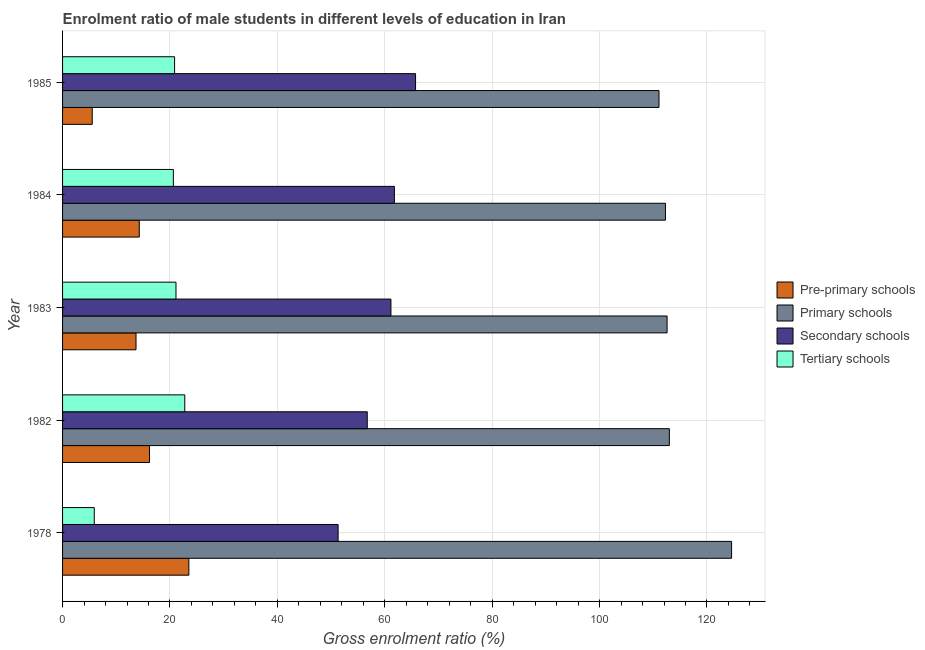How many groups of bars are there?
Give a very brief answer. 5. Are the number of bars per tick equal to the number of legend labels?
Give a very brief answer. Yes. Are the number of bars on each tick of the Y-axis equal?
Ensure brevity in your answer.  Yes. How many bars are there on the 2nd tick from the top?
Your answer should be compact. 4. What is the label of the 3rd group of bars from the top?
Your answer should be very brief. 1983. In how many cases, is the number of bars for a given year not equal to the number of legend labels?
Provide a succinct answer. 0. What is the gross enrolment ratio(female) in primary schools in 1985?
Make the answer very short. 111.07. Across all years, what is the maximum gross enrolment ratio(female) in primary schools?
Offer a terse response. 124.58. Across all years, what is the minimum gross enrolment ratio(female) in pre-primary schools?
Offer a very short reply. 5.52. In which year was the gross enrolment ratio(female) in secondary schools minimum?
Give a very brief answer. 1978. What is the total gross enrolment ratio(female) in secondary schools in the graph?
Offer a terse response. 296.73. What is the difference between the gross enrolment ratio(female) in tertiary schools in 1983 and that in 1984?
Your answer should be compact. 0.49. What is the difference between the gross enrolment ratio(female) in pre-primary schools in 1978 and the gross enrolment ratio(female) in secondary schools in 1982?
Provide a short and direct response. -33.22. What is the average gross enrolment ratio(female) in tertiary schools per year?
Ensure brevity in your answer.  18.25. In the year 1978, what is the difference between the gross enrolment ratio(female) in tertiary schools and gross enrolment ratio(female) in secondary schools?
Give a very brief answer. -45.41. What is the ratio of the gross enrolment ratio(female) in tertiary schools in 1983 to that in 1985?
Provide a short and direct response. 1.01. Is the difference between the gross enrolment ratio(female) in secondary schools in 1978 and 1983 greater than the difference between the gross enrolment ratio(female) in tertiary schools in 1978 and 1983?
Offer a very short reply. Yes. What is the difference between the highest and the second highest gross enrolment ratio(female) in pre-primary schools?
Keep it short and to the point. 7.33. What is the difference between the highest and the lowest gross enrolment ratio(female) in pre-primary schools?
Keep it short and to the point. 17.99. In how many years, is the gross enrolment ratio(female) in secondary schools greater than the average gross enrolment ratio(female) in secondary schools taken over all years?
Your response must be concise. 3. Is it the case that in every year, the sum of the gross enrolment ratio(female) in primary schools and gross enrolment ratio(female) in secondary schools is greater than the sum of gross enrolment ratio(female) in pre-primary schools and gross enrolment ratio(female) in tertiary schools?
Your answer should be very brief. Yes. What does the 3rd bar from the top in 1978 represents?
Ensure brevity in your answer.  Primary schools. What does the 4th bar from the bottom in 1984 represents?
Make the answer very short. Tertiary schools. Is it the case that in every year, the sum of the gross enrolment ratio(female) in pre-primary schools and gross enrolment ratio(female) in primary schools is greater than the gross enrolment ratio(female) in secondary schools?
Provide a short and direct response. Yes. How many bars are there?
Offer a terse response. 20. How many years are there in the graph?
Ensure brevity in your answer.  5. Does the graph contain any zero values?
Offer a terse response. No. How many legend labels are there?
Offer a very short reply. 4. How are the legend labels stacked?
Provide a succinct answer. Vertical. What is the title of the graph?
Ensure brevity in your answer.  Enrolment ratio of male students in different levels of education in Iran. What is the Gross enrolment ratio (%) of Pre-primary schools in 1978?
Offer a very short reply. 23.52. What is the Gross enrolment ratio (%) of Primary schools in 1978?
Your answer should be compact. 124.58. What is the Gross enrolment ratio (%) in Secondary schools in 1978?
Offer a terse response. 51.31. What is the Gross enrolment ratio (%) in Tertiary schools in 1978?
Offer a very short reply. 5.9. What is the Gross enrolment ratio (%) in Pre-primary schools in 1982?
Ensure brevity in your answer.  16.19. What is the Gross enrolment ratio (%) in Primary schools in 1982?
Keep it short and to the point. 113. What is the Gross enrolment ratio (%) in Secondary schools in 1982?
Provide a succinct answer. 56.74. What is the Gross enrolment ratio (%) of Tertiary schools in 1982?
Ensure brevity in your answer.  22.76. What is the Gross enrolment ratio (%) of Pre-primary schools in 1983?
Give a very brief answer. 13.68. What is the Gross enrolment ratio (%) of Primary schools in 1983?
Your answer should be very brief. 112.57. What is the Gross enrolment ratio (%) in Secondary schools in 1983?
Provide a short and direct response. 61.15. What is the Gross enrolment ratio (%) of Tertiary schools in 1983?
Make the answer very short. 21.12. What is the Gross enrolment ratio (%) of Pre-primary schools in 1984?
Ensure brevity in your answer.  14.29. What is the Gross enrolment ratio (%) in Primary schools in 1984?
Your answer should be very brief. 112.27. What is the Gross enrolment ratio (%) in Secondary schools in 1984?
Your answer should be very brief. 61.79. What is the Gross enrolment ratio (%) of Tertiary schools in 1984?
Offer a very short reply. 20.63. What is the Gross enrolment ratio (%) of Pre-primary schools in 1985?
Provide a short and direct response. 5.52. What is the Gross enrolment ratio (%) in Primary schools in 1985?
Your response must be concise. 111.07. What is the Gross enrolment ratio (%) in Secondary schools in 1985?
Provide a short and direct response. 65.74. What is the Gross enrolment ratio (%) of Tertiary schools in 1985?
Your response must be concise. 20.86. Across all years, what is the maximum Gross enrolment ratio (%) in Pre-primary schools?
Give a very brief answer. 23.52. Across all years, what is the maximum Gross enrolment ratio (%) of Primary schools?
Provide a short and direct response. 124.58. Across all years, what is the maximum Gross enrolment ratio (%) in Secondary schools?
Your answer should be very brief. 65.74. Across all years, what is the maximum Gross enrolment ratio (%) in Tertiary schools?
Your answer should be very brief. 22.76. Across all years, what is the minimum Gross enrolment ratio (%) of Pre-primary schools?
Offer a very short reply. 5.52. Across all years, what is the minimum Gross enrolment ratio (%) in Primary schools?
Keep it short and to the point. 111.07. Across all years, what is the minimum Gross enrolment ratio (%) in Secondary schools?
Provide a succinct answer. 51.31. Across all years, what is the minimum Gross enrolment ratio (%) of Tertiary schools?
Give a very brief answer. 5.9. What is the total Gross enrolment ratio (%) in Pre-primary schools in the graph?
Provide a succinct answer. 73.2. What is the total Gross enrolment ratio (%) of Primary schools in the graph?
Keep it short and to the point. 573.5. What is the total Gross enrolment ratio (%) in Secondary schools in the graph?
Make the answer very short. 296.73. What is the total Gross enrolment ratio (%) in Tertiary schools in the graph?
Keep it short and to the point. 91.28. What is the difference between the Gross enrolment ratio (%) of Pre-primary schools in 1978 and that in 1982?
Your answer should be compact. 7.33. What is the difference between the Gross enrolment ratio (%) of Primary schools in 1978 and that in 1982?
Your answer should be compact. 11.59. What is the difference between the Gross enrolment ratio (%) of Secondary schools in 1978 and that in 1982?
Ensure brevity in your answer.  -5.43. What is the difference between the Gross enrolment ratio (%) in Tertiary schools in 1978 and that in 1982?
Provide a short and direct response. -16.86. What is the difference between the Gross enrolment ratio (%) in Pre-primary schools in 1978 and that in 1983?
Provide a short and direct response. 9.84. What is the difference between the Gross enrolment ratio (%) in Primary schools in 1978 and that in 1983?
Provide a short and direct response. 12.01. What is the difference between the Gross enrolment ratio (%) in Secondary schools in 1978 and that in 1983?
Offer a very short reply. -9.84. What is the difference between the Gross enrolment ratio (%) of Tertiary schools in 1978 and that in 1983?
Provide a succinct answer. -15.22. What is the difference between the Gross enrolment ratio (%) in Pre-primary schools in 1978 and that in 1984?
Your response must be concise. 9.23. What is the difference between the Gross enrolment ratio (%) of Primary schools in 1978 and that in 1984?
Provide a succinct answer. 12.31. What is the difference between the Gross enrolment ratio (%) of Secondary schools in 1978 and that in 1984?
Provide a short and direct response. -10.48. What is the difference between the Gross enrolment ratio (%) in Tertiary schools in 1978 and that in 1984?
Provide a short and direct response. -14.73. What is the difference between the Gross enrolment ratio (%) in Pre-primary schools in 1978 and that in 1985?
Your response must be concise. 17.99. What is the difference between the Gross enrolment ratio (%) of Primary schools in 1978 and that in 1985?
Provide a succinct answer. 13.51. What is the difference between the Gross enrolment ratio (%) of Secondary schools in 1978 and that in 1985?
Offer a terse response. -14.42. What is the difference between the Gross enrolment ratio (%) in Tertiary schools in 1978 and that in 1985?
Give a very brief answer. -14.96. What is the difference between the Gross enrolment ratio (%) in Pre-primary schools in 1982 and that in 1983?
Your answer should be very brief. 2.51. What is the difference between the Gross enrolment ratio (%) in Primary schools in 1982 and that in 1983?
Your response must be concise. 0.43. What is the difference between the Gross enrolment ratio (%) of Secondary schools in 1982 and that in 1983?
Ensure brevity in your answer.  -4.41. What is the difference between the Gross enrolment ratio (%) in Tertiary schools in 1982 and that in 1983?
Offer a terse response. 1.64. What is the difference between the Gross enrolment ratio (%) in Pre-primary schools in 1982 and that in 1984?
Offer a very short reply. 1.9. What is the difference between the Gross enrolment ratio (%) in Primary schools in 1982 and that in 1984?
Your answer should be compact. 0.73. What is the difference between the Gross enrolment ratio (%) of Secondary schools in 1982 and that in 1984?
Make the answer very short. -5.06. What is the difference between the Gross enrolment ratio (%) of Tertiary schools in 1982 and that in 1984?
Make the answer very short. 2.13. What is the difference between the Gross enrolment ratio (%) of Pre-primary schools in 1982 and that in 1985?
Your answer should be compact. 10.66. What is the difference between the Gross enrolment ratio (%) in Primary schools in 1982 and that in 1985?
Provide a short and direct response. 1.93. What is the difference between the Gross enrolment ratio (%) in Secondary schools in 1982 and that in 1985?
Offer a terse response. -9. What is the difference between the Gross enrolment ratio (%) in Tertiary schools in 1982 and that in 1985?
Ensure brevity in your answer.  1.9. What is the difference between the Gross enrolment ratio (%) of Pre-primary schools in 1983 and that in 1984?
Offer a very short reply. -0.61. What is the difference between the Gross enrolment ratio (%) of Primary schools in 1983 and that in 1984?
Offer a very short reply. 0.3. What is the difference between the Gross enrolment ratio (%) of Secondary schools in 1983 and that in 1984?
Your answer should be compact. -0.64. What is the difference between the Gross enrolment ratio (%) of Tertiary schools in 1983 and that in 1984?
Make the answer very short. 0.49. What is the difference between the Gross enrolment ratio (%) in Pre-primary schools in 1983 and that in 1985?
Your answer should be compact. 8.15. What is the difference between the Gross enrolment ratio (%) of Primary schools in 1983 and that in 1985?
Provide a succinct answer. 1.5. What is the difference between the Gross enrolment ratio (%) in Secondary schools in 1983 and that in 1985?
Offer a very short reply. -4.59. What is the difference between the Gross enrolment ratio (%) in Tertiary schools in 1983 and that in 1985?
Provide a succinct answer. 0.26. What is the difference between the Gross enrolment ratio (%) in Pre-primary schools in 1984 and that in 1985?
Provide a short and direct response. 8.76. What is the difference between the Gross enrolment ratio (%) of Primary schools in 1984 and that in 1985?
Offer a very short reply. 1.2. What is the difference between the Gross enrolment ratio (%) of Secondary schools in 1984 and that in 1985?
Your answer should be compact. -3.94. What is the difference between the Gross enrolment ratio (%) in Tertiary schools in 1984 and that in 1985?
Keep it short and to the point. -0.23. What is the difference between the Gross enrolment ratio (%) of Pre-primary schools in 1978 and the Gross enrolment ratio (%) of Primary schools in 1982?
Your answer should be compact. -89.48. What is the difference between the Gross enrolment ratio (%) in Pre-primary schools in 1978 and the Gross enrolment ratio (%) in Secondary schools in 1982?
Give a very brief answer. -33.22. What is the difference between the Gross enrolment ratio (%) of Pre-primary schools in 1978 and the Gross enrolment ratio (%) of Tertiary schools in 1982?
Your response must be concise. 0.76. What is the difference between the Gross enrolment ratio (%) in Primary schools in 1978 and the Gross enrolment ratio (%) in Secondary schools in 1982?
Offer a terse response. 67.85. What is the difference between the Gross enrolment ratio (%) of Primary schools in 1978 and the Gross enrolment ratio (%) of Tertiary schools in 1982?
Offer a terse response. 101.83. What is the difference between the Gross enrolment ratio (%) of Secondary schools in 1978 and the Gross enrolment ratio (%) of Tertiary schools in 1982?
Provide a succinct answer. 28.55. What is the difference between the Gross enrolment ratio (%) in Pre-primary schools in 1978 and the Gross enrolment ratio (%) in Primary schools in 1983?
Your answer should be compact. -89.06. What is the difference between the Gross enrolment ratio (%) of Pre-primary schools in 1978 and the Gross enrolment ratio (%) of Secondary schools in 1983?
Your response must be concise. -37.63. What is the difference between the Gross enrolment ratio (%) of Pre-primary schools in 1978 and the Gross enrolment ratio (%) of Tertiary schools in 1983?
Give a very brief answer. 2.4. What is the difference between the Gross enrolment ratio (%) of Primary schools in 1978 and the Gross enrolment ratio (%) of Secondary schools in 1983?
Offer a very short reply. 63.43. What is the difference between the Gross enrolment ratio (%) of Primary schools in 1978 and the Gross enrolment ratio (%) of Tertiary schools in 1983?
Your answer should be very brief. 103.46. What is the difference between the Gross enrolment ratio (%) of Secondary schools in 1978 and the Gross enrolment ratio (%) of Tertiary schools in 1983?
Your response must be concise. 30.19. What is the difference between the Gross enrolment ratio (%) in Pre-primary schools in 1978 and the Gross enrolment ratio (%) in Primary schools in 1984?
Ensure brevity in your answer.  -88.75. What is the difference between the Gross enrolment ratio (%) in Pre-primary schools in 1978 and the Gross enrolment ratio (%) in Secondary schools in 1984?
Make the answer very short. -38.28. What is the difference between the Gross enrolment ratio (%) of Pre-primary schools in 1978 and the Gross enrolment ratio (%) of Tertiary schools in 1984?
Offer a very short reply. 2.89. What is the difference between the Gross enrolment ratio (%) of Primary schools in 1978 and the Gross enrolment ratio (%) of Secondary schools in 1984?
Offer a terse response. 62.79. What is the difference between the Gross enrolment ratio (%) in Primary schools in 1978 and the Gross enrolment ratio (%) in Tertiary schools in 1984?
Your answer should be very brief. 103.95. What is the difference between the Gross enrolment ratio (%) in Secondary schools in 1978 and the Gross enrolment ratio (%) in Tertiary schools in 1984?
Your answer should be very brief. 30.68. What is the difference between the Gross enrolment ratio (%) of Pre-primary schools in 1978 and the Gross enrolment ratio (%) of Primary schools in 1985?
Ensure brevity in your answer.  -87.55. What is the difference between the Gross enrolment ratio (%) of Pre-primary schools in 1978 and the Gross enrolment ratio (%) of Secondary schools in 1985?
Offer a terse response. -42.22. What is the difference between the Gross enrolment ratio (%) of Pre-primary schools in 1978 and the Gross enrolment ratio (%) of Tertiary schools in 1985?
Your answer should be very brief. 2.65. What is the difference between the Gross enrolment ratio (%) of Primary schools in 1978 and the Gross enrolment ratio (%) of Secondary schools in 1985?
Provide a short and direct response. 58.85. What is the difference between the Gross enrolment ratio (%) of Primary schools in 1978 and the Gross enrolment ratio (%) of Tertiary schools in 1985?
Give a very brief answer. 103.72. What is the difference between the Gross enrolment ratio (%) in Secondary schools in 1978 and the Gross enrolment ratio (%) in Tertiary schools in 1985?
Provide a succinct answer. 30.45. What is the difference between the Gross enrolment ratio (%) in Pre-primary schools in 1982 and the Gross enrolment ratio (%) in Primary schools in 1983?
Offer a very short reply. -96.38. What is the difference between the Gross enrolment ratio (%) in Pre-primary schools in 1982 and the Gross enrolment ratio (%) in Secondary schools in 1983?
Make the answer very short. -44.96. What is the difference between the Gross enrolment ratio (%) in Pre-primary schools in 1982 and the Gross enrolment ratio (%) in Tertiary schools in 1983?
Ensure brevity in your answer.  -4.93. What is the difference between the Gross enrolment ratio (%) of Primary schools in 1982 and the Gross enrolment ratio (%) of Secondary schools in 1983?
Provide a succinct answer. 51.85. What is the difference between the Gross enrolment ratio (%) of Primary schools in 1982 and the Gross enrolment ratio (%) of Tertiary schools in 1983?
Give a very brief answer. 91.88. What is the difference between the Gross enrolment ratio (%) in Secondary schools in 1982 and the Gross enrolment ratio (%) in Tertiary schools in 1983?
Provide a succinct answer. 35.62. What is the difference between the Gross enrolment ratio (%) of Pre-primary schools in 1982 and the Gross enrolment ratio (%) of Primary schools in 1984?
Offer a very short reply. -96.08. What is the difference between the Gross enrolment ratio (%) in Pre-primary schools in 1982 and the Gross enrolment ratio (%) in Secondary schools in 1984?
Give a very brief answer. -45.61. What is the difference between the Gross enrolment ratio (%) in Pre-primary schools in 1982 and the Gross enrolment ratio (%) in Tertiary schools in 1984?
Provide a succinct answer. -4.44. What is the difference between the Gross enrolment ratio (%) in Primary schools in 1982 and the Gross enrolment ratio (%) in Secondary schools in 1984?
Your answer should be very brief. 51.21. What is the difference between the Gross enrolment ratio (%) in Primary schools in 1982 and the Gross enrolment ratio (%) in Tertiary schools in 1984?
Provide a succinct answer. 92.37. What is the difference between the Gross enrolment ratio (%) of Secondary schools in 1982 and the Gross enrolment ratio (%) of Tertiary schools in 1984?
Your answer should be compact. 36.11. What is the difference between the Gross enrolment ratio (%) in Pre-primary schools in 1982 and the Gross enrolment ratio (%) in Primary schools in 1985?
Keep it short and to the point. -94.88. What is the difference between the Gross enrolment ratio (%) of Pre-primary schools in 1982 and the Gross enrolment ratio (%) of Secondary schools in 1985?
Make the answer very short. -49.55. What is the difference between the Gross enrolment ratio (%) in Pre-primary schools in 1982 and the Gross enrolment ratio (%) in Tertiary schools in 1985?
Your response must be concise. -4.67. What is the difference between the Gross enrolment ratio (%) of Primary schools in 1982 and the Gross enrolment ratio (%) of Secondary schools in 1985?
Keep it short and to the point. 47.26. What is the difference between the Gross enrolment ratio (%) in Primary schools in 1982 and the Gross enrolment ratio (%) in Tertiary schools in 1985?
Keep it short and to the point. 92.14. What is the difference between the Gross enrolment ratio (%) of Secondary schools in 1982 and the Gross enrolment ratio (%) of Tertiary schools in 1985?
Offer a terse response. 35.88. What is the difference between the Gross enrolment ratio (%) of Pre-primary schools in 1983 and the Gross enrolment ratio (%) of Primary schools in 1984?
Keep it short and to the point. -98.59. What is the difference between the Gross enrolment ratio (%) in Pre-primary schools in 1983 and the Gross enrolment ratio (%) in Secondary schools in 1984?
Provide a succinct answer. -48.12. What is the difference between the Gross enrolment ratio (%) in Pre-primary schools in 1983 and the Gross enrolment ratio (%) in Tertiary schools in 1984?
Your answer should be very brief. -6.95. What is the difference between the Gross enrolment ratio (%) in Primary schools in 1983 and the Gross enrolment ratio (%) in Secondary schools in 1984?
Offer a terse response. 50.78. What is the difference between the Gross enrolment ratio (%) of Primary schools in 1983 and the Gross enrolment ratio (%) of Tertiary schools in 1984?
Ensure brevity in your answer.  91.94. What is the difference between the Gross enrolment ratio (%) of Secondary schools in 1983 and the Gross enrolment ratio (%) of Tertiary schools in 1984?
Your answer should be very brief. 40.52. What is the difference between the Gross enrolment ratio (%) of Pre-primary schools in 1983 and the Gross enrolment ratio (%) of Primary schools in 1985?
Your answer should be very brief. -97.39. What is the difference between the Gross enrolment ratio (%) in Pre-primary schools in 1983 and the Gross enrolment ratio (%) in Secondary schools in 1985?
Provide a succinct answer. -52.06. What is the difference between the Gross enrolment ratio (%) of Pre-primary schools in 1983 and the Gross enrolment ratio (%) of Tertiary schools in 1985?
Provide a succinct answer. -7.18. What is the difference between the Gross enrolment ratio (%) of Primary schools in 1983 and the Gross enrolment ratio (%) of Secondary schools in 1985?
Make the answer very short. 46.84. What is the difference between the Gross enrolment ratio (%) of Primary schools in 1983 and the Gross enrolment ratio (%) of Tertiary schools in 1985?
Ensure brevity in your answer.  91.71. What is the difference between the Gross enrolment ratio (%) in Secondary schools in 1983 and the Gross enrolment ratio (%) in Tertiary schools in 1985?
Provide a short and direct response. 40.29. What is the difference between the Gross enrolment ratio (%) in Pre-primary schools in 1984 and the Gross enrolment ratio (%) in Primary schools in 1985?
Offer a very short reply. -96.78. What is the difference between the Gross enrolment ratio (%) of Pre-primary schools in 1984 and the Gross enrolment ratio (%) of Secondary schools in 1985?
Keep it short and to the point. -51.45. What is the difference between the Gross enrolment ratio (%) of Pre-primary schools in 1984 and the Gross enrolment ratio (%) of Tertiary schools in 1985?
Make the answer very short. -6.58. What is the difference between the Gross enrolment ratio (%) of Primary schools in 1984 and the Gross enrolment ratio (%) of Secondary schools in 1985?
Provide a succinct answer. 46.53. What is the difference between the Gross enrolment ratio (%) of Primary schools in 1984 and the Gross enrolment ratio (%) of Tertiary schools in 1985?
Give a very brief answer. 91.41. What is the difference between the Gross enrolment ratio (%) in Secondary schools in 1984 and the Gross enrolment ratio (%) in Tertiary schools in 1985?
Offer a very short reply. 40.93. What is the average Gross enrolment ratio (%) in Pre-primary schools per year?
Ensure brevity in your answer.  14.64. What is the average Gross enrolment ratio (%) in Primary schools per year?
Keep it short and to the point. 114.7. What is the average Gross enrolment ratio (%) in Secondary schools per year?
Your response must be concise. 59.35. What is the average Gross enrolment ratio (%) of Tertiary schools per year?
Keep it short and to the point. 18.26. In the year 1978, what is the difference between the Gross enrolment ratio (%) in Pre-primary schools and Gross enrolment ratio (%) in Primary schools?
Offer a very short reply. -101.07. In the year 1978, what is the difference between the Gross enrolment ratio (%) in Pre-primary schools and Gross enrolment ratio (%) in Secondary schools?
Ensure brevity in your answer.  -27.8. In the year 1978, what is the difference between the Gross enrolment ratio (%) in Pre-primary schools and Gross enrolment ratio (%) in Tertiary schools?
Give a very brief answer. 17.62. In the year 1978, what is the difference between the Gross enrolment ratio (%) of Primary schools and Gross enrolment ratio (%) of Secondary schools?
Make the answer very short. 73.27. In the year 1978, what is the difference between the Gross enrolment ratio (%) in Primary schools and Gross enrolment ratio (%) in Tertiary schools?
Offer a very short reply. 118.68. In the year 1978, what is the difference between the Gross enrolment ratio (%) of Secondary schools and Gross enrolment ratio (%) of Tertiary schools?
Offer a very short reply. 45.41. In the year 1982, what is the difference between the Gross enrolment ratio (%) in Pre-primary schools and Gross enrolment ratio (%) in Primary schools?
Your answer should be compact. -96.81. In the year 1982, what is the difference between the Gross enrolment ratio (%) of Pre-primary schools and Gross enrolment ratio (%) of Secondary schools?
Your response must be concise. -40.55. In the year 1982, what is the difference between the Gross enrolment ratio (%) in Pre-primary schools and Gross enrolment ratio (%) in Tertiary schools?
Make the answer very short. -6.57. In the year 1982, what is the difference between the Gross enrolment ratio (%) of Primary schools and Gross enrolment ratio (%) of Secondary schools?
Keep it short and to the point. 56.26. In the year 1982, what is the difference between the Gross enrolment ratio (%) in Primary schools and Gross enrolment ratio (%) in Tertiary schools?
Your answer should be very brief. 90.24. In the year 1982, what is the difference between the Gross enrolment ratio (%) in Secondary schools and Gross enrolment ratio (%) in Tertiary schools?
Your answer should be very brief. 33.98. In the year 1983, what is the difference between the Gross enrolment ratio (%) in Pre-primary schools and Gross enrolment ratio (%) in Primary schools?
Provide a short and direct response. -98.89. In the year 1983, what is the difference between the Gross enrolment ratio (%) of Pre-primary schools and Gross enrolment ratio (%) of Secondary schools?
Offer a terse response. -47.47. In the year 1983, what is the difference between the Gross enrolment ratio (%) of Pre-primary schools and Gross enrolment ratio (%) of Tertiary schools?
Keep it short and to the point. -7.44. In the year 1983, what is the difference between the Gross enrolment ratio (%) in Primary schools and Gross enrolment ratio (%) in Secondary schools?
Offer a very short reply. 51.42. In the year 1983, what is the difference between the Gross enrolment ratio (%) in Primary schools and Gross enrolment ratio (%) in Tertiary schools?
Your answer should be compact. 91.45. In the year 1983, what is the difference between the Gross enrolment ratio (%) in Secondary schools and Gross enrolment ratio (%) in Tertiary schools?
Your answer should be compact. 40.03. In the year 1984, what is the difference between the Gross enrolment ratio (%) of Pre-primary schools and Gross enrolment ratio (%) of Primary schools?
Your answer should be compact. -97.98. In the year 1984, what is the difference between the Gross enrolment ratio (%) of Pre-primary schools and Gross enrolment ratio (%) of Secondary schools?
Offer a very short reply. -47.51. In the year 1984, what is the difference between the Gross enrolment ratio (%) in Pre-primary schools and Gross enrolment ratio (%) in Tertiary schools?
Provide a succinct answer. -6.34. In the year 1984, what is the difference between the Gross enrolment ratio (%) of Primary schools and Gross enrolment ratio (%) of Secondary schools?
Offer a very short reply. 50.48. In the year 1984, what is the difference between the Gross enrolment ratio (%) in Primary schools and Gross enrolment ratio (%) in Tertiary schools?
Your response must be concise. 91.64. In the year 1984, what is the difference between the Gross enrolment ratio (%) of Secondary schools and Gross enrolment ratio (%) of Tertiary schools?
Provide a succinct answer. 41.16. In the year 1985, what is the difference between the Gross enrolment ratio (%) in Pre-primary schools and Gross enrolment ratio (%) in Primary schools?
Your answer should be very brief. -105.55. In the year 1985, what is the difference between the Gross enrolment ratio (%) of Pre-primary schools and Gross enrolment ratio (%) of Secondary schools?
Offer a very short reply. -60.21. In the year 1985, what is the difference between the Gross enrolment ratio (%) of Pre-primary schools and Gross enrolment ratio (%) of Tertiary schools?
Offer a terse response. -15.34. In the year 1985, what is the difference between the Gross enrolment ratio (%) of Primary schools and Gross enrolment ratio (%) of Secondary schools?
Offer a very short reply. 45.33. In the year 1985, what is the difference between the Gross enrolment ratio (%) of Primary schools and Gross enrolment ratio (%) of Tertiary schools?
Offer a terse response. 90.21. In the year 1985, what is the difference between the Gross enrolment ratio (%) of Secondary schools and Gross enrolment ratio (%) of Tertiary schools?
Make the answer very short. 44.87. What is the ratio of the Gross enrolment ratio (%) in Pre-primary schools in 1978 to that in 1982?
Provide a succinct answer. 1.45. What is the ratio of the Gross enrolment ratio (%) of Primary schools in 1978 to that in 1982?
Give a very brief answer. 1.1. What is the ratio of the Gross enrolment ratio (%) of Secondary schools in 1978 to that in 1982?
Your answer should be very brief. 0.9. What is the ratio of the Gross enrolment ratio (%) of Tertiary schools in 1978 to that in 1982?
Your response must be concise. 0.26. What is the ratio of the Gross enrolment ratio (%) in Pre-primary schools in 1978 to that in 1983?
Your answer should be compact. 1.72. What is the ratio of the Gross enrolment ratio (%) in Primary schools in 1978 to that in 1983?
Your answer should be compact. 1.11. What is the ratio of the Gross enrolment ratio (%) of Secondary schools in 1978 to that in 1983?
Offer a very short reply. 0.84. What is the ratio of the Gross enrolment ratio (%) in Tertiary schools in 1978 to that in 1983?
Provide a short and direct response. 0.28. What is the ratio of the Gross enrolment ratio (%) of Pre-primary schools in 1978 to that in 1984?
Offer a very short reply. 1.65. What is the ratio of the Gross enrolment ratio (%) in Primary schools in 1978 to that in 1984?
Provide a short and direct response. 1.11. What is the ratio of the Gross enrolment ratio (%) in Secondary schools in 1978 to that in 1984?
Keep it short and to the point. 0.83. What is the ratio of the Gross enrolment ratio (%) of Tertiary schools in 1978 to that in 1984?
Your answer should be very brief. 0.29. What is the ratio of the Gross enrolment ratio (%) in Pre-primary schools in 1978 to that in 1985?
Provide a succinct answer. 4.26. What is the ratio of the Gross enrolment ratio (%) in Primary schools in 1978 to that in 1985?
Give a very brief answer. 1.12. What is the ratio of the Gross enrolment ratio (%) of Secondary schools in 1978 to that in 1985?
Ensure brevity in your answer.  0.78. What is the ratio of the Gross enrolment ratio (%) in Tertiary schools in 1978 to that in 1985?
Keep it short and to the point. 0.28. What is the ratio of the Gross enrolment ratio (%) in Pre-primary schools in 1982 to that in 1983?
Offer a very short reply. 1.18. What is the ratio of the Gross enrolment ratio (%) in Secondary schools in 1982 to that in 1983?
Make the answer very short. 0.93. What is the ratio of the Gross enrolment ratio (%) of Tertiary schools in 1982 to that in 1983?
Provide a short and direct response. 1.08. What is the ratio of the Gross enrolment ratio (%) of Pre-primary schools in 1982 to that in 1984?
Offer a terse response. 1.13. What is the ratio of the Gross enrolment ratio (%) in Secondary schools in 1982 to that in 1984?
Make the answer very short. 0.92. What is the ratio of the Gross enrolment ratio (%) of Tertiary schools in 1982 to that in 1984?
Your response must be concise. 1.1. What is the ratio of the Gross enrolment ratio (%) in Pre-primary schools in 1982 to that in 1985?
Offer a very short reply. 2.93. What is the ratio of the Gross enrolment ratio (%) in Primary schools in 1982 to that in 1985?
Ensure brevity in your answer.  1.02. What is the ratio of the Gross enrolment ratio (%) in Secondary schools in 1982 to that in 1985?
Give a very brief answer. 0.86. What is the ratio of the Gross enrolment ratio (%) in Tertiary schools in 1982 to that in 1985?
Your answer should be very brief. 1.09. What is the ratio of the Gross enrolment ratio (%) of Pre-primary schools in 1983 to that in 1984?
Your answer should be compact. 0.96. What is the ratio of the Gross enrolment ratio (%) of Tertiary schools in 1983 to that in 1984?
Offer a very short reply. 1.02. What is the ratio of the Gross enrolment ratio (%) of Pre-primary schools in 1983 to that in 1985?
Your answer should be very brief. 2.48. What is the ratio of the Gross enrolment ratio (%) of Primary schools in 1983 to that in 1985?
Offer a terse response. 1.01. What is the ratio of the Gross enrolment ratio (%) in Secondary schools in 1983 to that in 1985?
Provide a succinct answer. 0.93. What is the ratio of the Gross enrolment ratio (%) of Tertiary schools in 1983 to that in 1985?
Your response must be concise. 1.01. What is the ratio of the Gross enrolment ratio (%) in Pre-primary schools in 1984 to that in 1985?
Provide a succinct answer. 2.59. What is the ratio of the Gross enrolment ratio (%) of Primary schools in 1984 to that in 1985?
Offer a terse response. 1.01. What is the ratio of the Gross enrolment ratio (%) in Tertiary schools in 1984 to that in 1985?
Make the answer very short. 0.99. What is the difference between the highest and the second highest Gross enrolment ratio (%) of Pre-primary schools?
Make the answer very short. 7.33. What is the difference between the highest and the second highest Gross enrolment ratio (%) in Primary schools?
Your answer should be compact. 11.59. What is the difference between the highest and the second highest Gross enrolment ratio (%) in Secondary schools?
Give a very brief answer. 3.94. What is the difference between the highest and the second highest Gross enrolment ratio (%) in Tertiary schools?
Make the answer very short. 1.64. What is the difference between the highest and the lowest Gross enrolment ratio (%) in Pre-primary schools?
Give a very brief answer. 17.99. What is the difference between the highest and the lowest Gross enrolment ratio (%) of Primary schools?
Your answer should be very brief. 13.51. What is the difference between the highest and the lowest Gross enrolment ratio (%) of Secondary schools?
Offer a terse response. 14.42. What is the difference between the highest and the lowest Gross enrolment ratio (%) in Tertiary schools?
Your answer should be very brief. 16.86. 